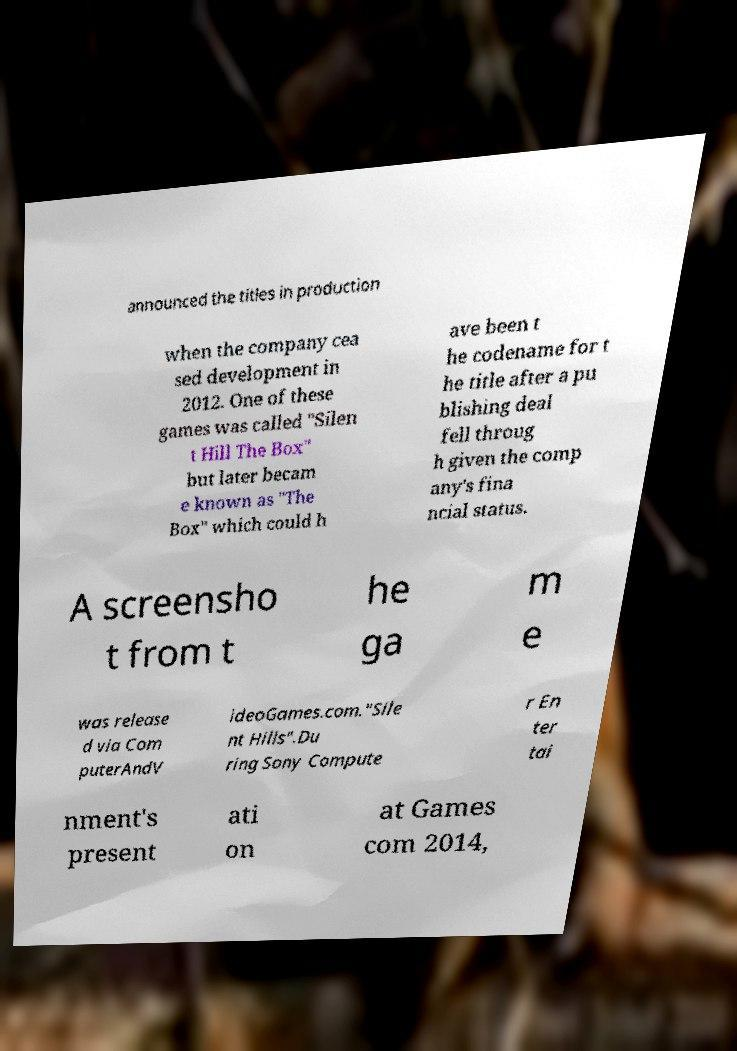I need the written content from this picture converted into text. Can you do that? announced the titles in production when the company cea sed development in 2012. One of these games was called "Silen t Hill The Box" but later becam e known as "The Box" which could h ave been t he codename for t he title after a pu blishing deal fell throug h given the comp any's fina ncial status. A screensho t from t he ga m e was release d via Com puterAndV ideoGames.com."Sile nt Hills".Du ring Sony Compute r En ter tai nment's present ati on at Games com 2014, 